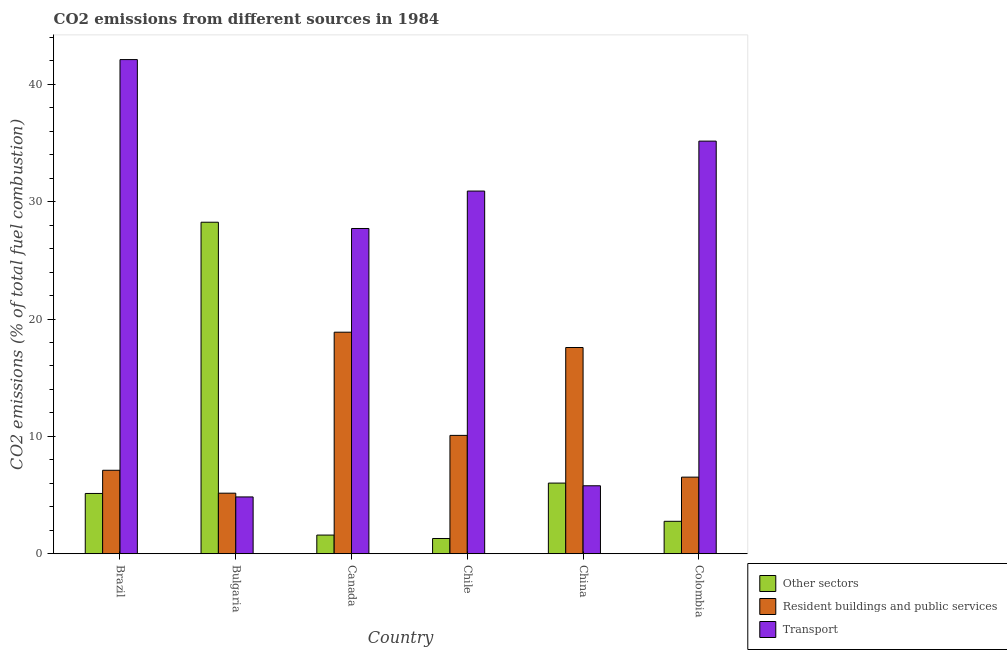How many different coloured bars are there?
Your answer should be compact. 3. How many groups of bars are there?
Give a very brief answer. 6. Are the number of bars on each tick of the X-axis equal?
Your answer should be compact. Yes. How many bars are there on the 1st tick from the right?
Your answer should be very brief. 3. What is the percentage of co2 emissions from resident buildings and public services in Brazil?
Offer a very short reply. 7.11. Across all countries, what is the maximum percentage of co2 emissions from transport?
Make the answer very short. 42.11. Across all countries, what is the minimum percentage of co2 emissions from resident buildings and public services?
Give a very brief answer. 5.16. In which country was the percentage of co2 emissions from resident buildings and public services minimum?
Provide a short and direct response. Bulgaria. What is the total percentage of co2 emissions from other sectors in the graph?
Keep it short and to the point. 45.05. What is the difference between the percentage of co2 emissions from transport in Brazil and that in Chile?
Keep it short and to the point. 11.2. What is the difference between the percentage of co2 emissions from other sectors in China and the percentage of co2 emissions from transport in Colombia?
Give a very brief answer. -29.14. What is the average percentage of co2 emissions from other sectors per country?
Your response must be concise. 7.51. What is the difference between the percentage of co2 emissions from other sectors and percentage of co2 emissions from resident buildings and public services in Chile?
Provide a short and direct response. -8.79. In how many countries, is the percentage of co2 emissions from other sectors greater than 40 %?
Provide a short and direct response. 0. What is the ratio of the percentage of co2 emissions from other sectors in Bulgaria to that in Canada?
Your answer should be compact. 17.77. Is the difference between the percentage of co2 emissions from other sectors in Chile and China greater than the difference between the percentage of co2 emissions from transport in Chile and China?
Provide a short and direct response. No. What is the difference between the highest and the second highest percentage of co2 emissions from other sectors?
Keep it short and to the point. 22.23. What is the difference between the highest and the lowest percentage of co2 emissions from resident buildings and public services?
Ensure brevity in your answer.  13.72. What does the 2nd bar from the left in China represents?
Provide a short and direct response. Resident buildings and public services. What does the 3rd bar from the right in Chile represents?
Offer a very short reply. Other sectors. How many bars are there?
Offer a terse response. 18. Are all the bars in the graph horizontal?
Ensure brevity in your answer.  No. What is the difference between two consecutive major ticks on the Y-axis?
Give a very brief answer. 10. Are the values on the major ticks of Y-axis written in scientific E-notation?
Give a very brief answer. No. Where does the legend appear in the graph?
Make the answer very short. Bottom right. How many legend labels are there?
Your answer should be compact. 3. What is the title of the graph?
Make the answer very short. CO2 emissions from different sources in 1984. What is the label or title of the X-axis?
Provide a short and direct response. Country. What is the label or title of the Y-axis?
Offer a terse response. CO2 emissions (% of total fuel combustion). What is the CO2 emissions (% of total fuel combustion) of Other sectors in Brazil?
Offer a terse response. 5.13. What is the CO2 emissions (% of total fuel combustion) of Resident buildings and public services in Brazil?
Your answer should be very brief. 7.11. What is the CO2 emissions (% of total fuel combustion) in Transport in Brazil?
Your response must be concise. 42.11. What is the CO2 emissions (% of total fuel combustion) in Other sectors in Bulgaria?
Your answer should be compact. 28.25. What is the CO2 emissions (% of total fuel combustion) of Resident buildings and public services in Bulgaria?
Offer a terse response. 5.16. What is the CO2 emissions (% of total fuel combustion) in Transport in Bulgaria?
Your response must be concise. 4.84. What is the CO2 emissions (% of total fuel combustion) of Other sectors in Canada?
Your answer should be compact. 1.59. What is the CO2 emissions (% of total fuel combustion) in Resident buildings and public services in Canada?
Make the answer very short. 18.88. What is the CO2 emissions (% of total fuel combustion) in Transport in Canada?
Provide a succinct answer. 27.71. What is the CO2 emissions (% of total fuel combustion) in Other sectors in Chile?
Ensure brevity in your answer.  1.3. What is the CO2 emissions (% of total fuel combustion) in Resident buildings and public services in Chile?
Offer a terse response. 10.08. What is the CO2 emissions (% of total fuel combustion) in Transport in Chile?
Keep it short and to the point. 30.9. What is the CO2 emissions (% of total fuel combustion) of Other sectors in China?
Ensure brevity in your answer.  6.02. What is the CO2 emissions (% of total fuel combustion) in Resident buildings and public services in China?
Your answer should be compact. 17.57. What is the CO2 emissions (% of total fuel combustion) of Transport in China?
Offer a very short reply. 5.79. What is the CO2 emissions (% of total fuel combustion) of Other sectors in Colombia?
Give a very brief answer. 2.76. What is the CO2 emissions (% of total fuel combustion) of Resident buildings and public services in Colombia?
Your response must be concise. 6.53. What is the CO2 emissions (% of total fuel combustion) of Transport in Colombia?
Your answer should be very brief. 35.16. Across all countries, what is the maximum CO2 emissions (% of total fuel combustion) of Other sectors?
Offer a terse response. 28.25. Across all countries, what is the maximum CO2 emissions (% of total fuel combustion) of Resident buildings and public services?
Make the answer very short. 18.88. Across all countries, what is the maximum CO2 emissions (% of total fuel combustion) in Transport?
Provide a short and direct response. 42.11. Across all countries, what is the minimum CO2 emissions (% of total fuel combustion) of Other sectors?
Offer a terse response. 1.3. Across all countries, what is the minimum CO2 emissions (% of total fuel combustion) in Resident buildings and public services?
Offer a terse response. 5.16. Across all countries, what is the minimum CO2 emissions (% of total fuel combustion) of Transport?
Give a very brief answer. 4.84. What is the total CO2 emissions (% of total fuel combustion) in Other sectors in the graph?
Provide a succinct answer. 45.05. What is the total CO2 emissions (% of total fuel combustion) of Resident buildings and public services in the graph?
Provide a succinct answer. 65.33. What is the total CO2 emissions (% of total fuel combustion) in Transport in the graph?
Give a very brief answer. 146.51. What is the difference between the CO2 emissions (% of total fuel combustion) of Other sectors in Brazil and that in Bulgaria?
Provide a succinct answer. -23.11. What is the difference between the CO2 emissions (% of total fuel combustion) of Resident buildings and public services in Brazil and that in Bulgaria?
Your answer should be very brief. 1.95. What is the difference between the CO2 emissions (% of total fuel combustion) of Transport in Brazil and that in Bulgaria?
Offer a very short reply. 37.27. What is the difference between the CO2 emissions (% of total fuel combustion) of Other sectors in Brazil and that in Canada?
Your answer should be compact. 3.55. What is the difference between the CO2 emissions (% of total fuel combustion) in Resident buildings and public services in Brazil and that in Canada?
Ensure brevity in your answer.  -11.77. What is the difference between the CO2 emissions (% of total fuel combustion) of Transport in Brazil and that in Canada?
Your answer should be compact. 14.39. What is the difference between the CO2 emissions (% of total fuel combustion) in Other sectors in Brazil and that in Chile?
Your response must be concise. 3.84. What is the difference between the CO2 emissions (% of total fuel combustion) in Resident buildings and public services in Brazil and that in Chile?
Make the answer very short. -2.97. What is the difference between the CO2 emissions (% of total fuel combustion) of Transport in Brazil and that in Chile?
Your answer should be compact. 11.2. What is the difference between the CO2 emissions (% of total fuel combustion) in Other sectors in Brazil and that in China?
Offer a terse response. -0.88. What is the difference between the CO2 emissions (% of total fuel combustion) of Resident buildings and public services in Brazil and that in China?
Give a very brief answer. -10.46. What is the difference between the CO2 emissions (% of total fuel combustion) of Transport in Brazil and that in China?
Your answer should be very brief. 36.32. What is the difference between the CO2 emissions (% of total fuel combustion) of Other sectors in Brazil and that in Colombia?
Your response must be concise. 2.37. What is the difference between the CO2 emissions (% of total fuel combustion) in Resident buildings and public services in Brazil and that in Colombia?
Keep it short and to the point. 0.58. What is the difference between the CO2 emissions (% of total fuel combustion) of Transport in Brazil and that in Colombia?
Keep it short and to the point. 6.95. What is the difference between the CO2 emissions (% of total fuel combustion) of Other sectors in Bulgaria and that in Canada?
Give a very brief answer. 26.66. What is the difference between the CO2 emissions (% of total fuel combustion) of Resident buildings and public services in Bulgaria and that in Canada?
Offer a terse response. -13.72. What is the difference between the CO2 emissions (% of total fuel combustion) in Transport in Bulgaria and that in Canada?
Your answer should be very brief. -22.87. What is the difference between the CO2 emissions (% of total fuel combustion) in Other sectors in Bulgaria and that in Chile?
Make the answer very short. 26.95. What is the difference between the CO2 emissions (% of total fuel combustion) of Resident buildings and public services in Bulgaria and that in Chile?
Ensure brevity in your answer.  -4.93. What is the difference between the CO2 emissions (% of total fuel combustion) of Transport in Bulgaria and that in Chile?
Your answer should be compact. -26.06. What is the difference between the CO2 emissions (% of total fuel combustion) in Other sectors in Bulgaria and that in China?
Keep it short and to the point. 22.23. What is the difference between the CO2 emissions (% of total fuel combustion) of Resident buildings and public services in Bulgaria and that in China?
Ensure brevity in your answer.  -12.41. What is the difference between the CO2 emissions (% of total fuel combustion) in Transport in Bulgaria and that in China?
Offer a very short reply. -0.95. What is the difference between the CO2 emissions (% of total fuel combustion) of Other sectors in Bulgaria and that in Colombia?
Offer a terse response. 25.48. What is the difference between the CO2 emissions (% of total fuel combustion) in Resident buildings and public services in Bulgaria and that in Colombia?
Your answer should be very brief. -1.37. What is the difference between the CO2 emissions (% of total fuel combustion) in Transport in Bulgaria and that in Colombia?
Offer a terse response. -30.32. What is the difference between the CO2 emissions (% of total fuel combustion) of Other sectors in Canada and that in Chile?
Your answer should be compact. 0.29. What is the difference between the CO2 emissions (% of total fuel combustion) in Resident buildings and public services in Canada and that in Chile?
Give a very brief answer. 8.79. What is the difference between the CO2 emissions (% of total fuel combustion) in Transport in Canada and that in Chile?
Offer a very short reply. -3.19. What is the difference between the CO2 emissions (% of total fuel combustion) in Other sectors in Canada and that in China?
Offer a very short reply. -4.43. What is the difference between the CO2 emissions (% of total fuel combustion) of Resident buildings and public services in Canada and that in China?
Offer a very short reply. 1.3. What is the difference between the CO2 emissions (% of total fuel combustion) in Transport in Canada and that in China?
Keep it short and to the point. 21.92. What is the difference between the CO2 emissions (% of total fuel combustion) in Other sectors in Canada and that in Colombia?
Keep it short and to the point. -1.17. What is the difference between the CO2 emissions (% of total fuel combustion) in Resident buildings and public services in Canada and that in Colombia?
Make the answer very short. 12.35. What is the difference between the CO2 emissions (% of total fuel combustion) in Transport in Canada and that in Colombia?
Make the answer very short. -7.45. What is the difference between the CO2 emissions (% of total fuel combustion) in Other sectors in Chile and that in China?
Your answer should be very brief. -4.72. What is the difference between the CO2 emissions (% of total fuel combustion) in Resident buildings and public services in Chile and that in China?
Your response must be concise. -7.49. What is the difference between the CO2 emissions (% of total fuel combustion) in Transport in Chile and that in China?
Provide a short and direct response. 25.11. What is the difference between the CO2 emissions (% of total fuel combustion) of Other sectors in Chile and that in Colombia?
Keep it short and to the point. -1.47. What is the difference between the CO2 emissions (% of total fuel combustion) in Resident buildings and public services in Chile and that in Colombia?
Give a very brief answer. 3.56. What is the difference between the CO2 emissions (% of total fuel combustion) in Transport in Chile and that in Colombia?
Your response must be concise. -4.25. What is the difference between the CO2 emissions (% of total fuel combustion) in Other sectors in China and that in Colombia?
Offer a very short reply. 3.26. What is the difference between the CO2 emissions (% of total fuel combustion) in Resident buildings and public services in China and that in Colombia?
Your answer should be very brief. 11.05. What is the difference between the CO2 emissions (% of total fuel combustion) in Transport in China and that in Colombia?
Your answer should be compact. -29.37. What is the difference between the CO2 emissions (% of total fuel combustion) of Other sectors in Brazil and the CO2 emissions (% of total fuel combustion) of Resident buildings and public services in Bulgaria?
Ensure brevity in your answer.  -0.02. What is the difference between the CO2 emissions (% of total fuel combustion) of Other sectors in Brazil and the CO2 emissions (% of total fuel combustion) of Transport in Bulgaria?
Provide a succinct answer. 0.3. What is the difference between the CO2 emissions (% of total fuel combustion) of Resident buildings and public services in Brazil and the CO2 emissions (% of total fuel combustion) of Transport in Bulgaria?
Offer a terse response. 2.27. What is the difference between the CO2 emissions (% of total fuel combustion) in Other sectors in Brazil and the CO2 emissions (% of total fuel combustion) in Resident buildings and public services in Canada?
Your answer should be compact. -13.74. What is the difference between the CO2 emissions (% of total fuel combustion) in Other sectors in Brazil and the CO2 emissions (% of total fuel combustion) in Transport in Canada?
Provide a succinct answer. -22.58. What is the difference between the CO2 emissions (% of total fuel combustion) in Resident buildings and public services in Brazil and the CO2 emissions (% of total fuel combustion) in Transport in Canada?
Provide a succinct answer. -20.6. What is the difference between the CO2 emissions (% of total fuel combustion) of Other sectors in Brazil and the CO2 emissions (% of total fuel combustion) of Resident buildings and public services in Chile?
Keep it short and to the point. -4.95. What is the difference between the CO2 emissions (% of total fuel combustion) in Other sectors in Brazil and the CO2 emissions (% of total fuel combustion) in Transport in Chile?
Your response must be concise. -25.77. What is the difference between the CO2 emissions (% of total fuel combustion) of Resident buildings and public services in Brazil and the CO2 emissions (% of total fuel combustion) of Transport in Chile?
Offer a terse response. -23.79. What is the difference between the CO2 emissions (% of total fuel combustion) of Other sectors in Brazil and the CO2 emissions (% of total fuel combustion) of Resident buildings and public services in China?
Keep it short and to the point. -12.44. What is the difference between the CO2 emissions (% of total fuel combustion) of Other sectors in Brazil and the CO2 emissions (% of total fuel combustion) of Transport in China?
Provide a succinct answer. -0.66. What is the difference between the CO2 emissions (% of total fuel combustion) in Resident buildings and public services in Brazil and the CO2 emissions (% of total fuel combustion) in Transport in China?
Offer a very short reply. 1.32. What is the difference between the CO2 emissions (% of total fuel combustion) of Other sectors in Brazil and the CO2 emissions (% of total fuel combustion) of Resident buildings and public services in Colombia?
Your response must be concise. -1.39. What is the difference between the CO2 emissions (% of total fuel combustion) in Other sectors in Brazil and the CO2 emissions (% of total fuel combustion) in Transport in Colombia?
Provide a short and direct response. -30.02. What is the difference between the CO2 emissions (% of total fuel combustion) of Resident buildings and public services in Brazil and the CO2 emissions (% of total fuel combustion) of Transport in Colombia?
Your answer should be compact. -28.05. What is the difference between the CO2 emissions (% of total fuel combustion) in Other sectors in Bulgaria and the CO2 emissions (% of total fuel combustion) in Resident buildings and public services in Canada?
Provide a short and direct response. 9.37. What is the difference between the CO2 emissions (% of total fuel combustion) in Other sectors in Bulgaria and the CO2 emissions (% of total fuel combustion) in Transport in Canada?
Offer a very short reply. 0.53. What is the difference between the CO2 emissions (% of total fuel combustion) in Resident buildings and public services in Bulgaria and the CO2 emissions (% of total fuel combustion) in Transport in Canada?
Offer a very short reply. -22.55. What is the difference between the CO2 emissions (% of total fuel combustion) in Other sectors in Bulgaria and the CO2 emissions (% of total fuel combustion) in Resident buildings and public services in Chile?
Your answer should be very brief. 18.16. What is the difference between the CO2 emissions (% of total fuel combustion) of Other sectors in Bulgaria and the CO2 emissions (% of total fuel combustion) of Transport in Chile?
Your answer should be compact. -2.66. What is the difference between the CO2 emissions (% of total fuel combustion) of Resident buildings and public services in Bulgaria and the CO2 emissions (% of total fuel combustion) of Transport in Chile?
Offer a terse response. -25.74. What is the difference between the CO2 emissions (% of total fuel combustion) in Other sectors in Bulgaria and the CO2 emissions (% of total fuel combustion) in Resident buildings and public services in China?
Give a very brief answer. 10.68. What is the difference between the CO2 emissions (% of total fuel combustion) of Other sectors in Bulgaria and the CO2 emissions (% of total fuel combustion) of Transport in China?
Your response must be concise. 22.46. What is the difference between the CO2 emissions (% of total fuel combustion) of Resident buildings and public services in Bulgaria and the CO2 emissions (% of total fuel combustion) of Transport in China?
Give a very brief answer. -0.63. What is the difference between the CO2 emissions (% of total fuel combustion) of Other sectors in Bulgaria and the CO2 emissions (% of total fuel combustion) of Resident buildings and public services in Colombia?
Your answer should be very brief. 21.72. What is the difference between the CO2 emissions (% of total fuel combustion) in Other sectors in Bulgaria and the CO2 emissions (% of total fuel combustion) in Transport in Colombia?
Offer a terse response. -6.91. What is the difference between the CO2 emissions (% of total fuel combustion) in Resident buildings and public services in Bulgaria and the CO2 emissions (% of total fuel combustion) in Transport in Colombia?
Keep it short and to the point. -30. What is the difference between the CO2 emissions (% of total fuel combustion) in Other sectors in Canada and the CO2 emissions (% of total fuel combustion) in Resident buildings and public services in Chile?
Your answer should be compact. -8.49. What is the difference between the CO2 emissions (% of total fuel combustion) of Other sectors in Canada and the CO2 emissions (% of total fuel combustion) of Transport in Chile?
Provide a succinct answer. -29.31. What is the difference between the CO2 emissions (% of total fuel combustion) in Resident buildings and public services in Canada and the CO2 emissions (% of total fuel combustion) in Transport in Chile?
Make the answer very short. -12.03. What is the difference between the CO2 emissions (% of total fuel combustion) in Other sectors in Canada and the CO2 emissions (% of total fuel combustion) in Resident buildings and public services in China?
Provide a succinct answer. -15.98. What is the difference between the CO2 emissions (% of total fuel combustion) of Other sectors in Canada and the CO2 emissions (% of total fuel combustion) of Transport in China?
Keep it short and to the point. -4.2. What is the difference between the CO2 emissions (% of total fuel combustion) in Resident buildings and public services in Canada and the CO2 emissions (% of total fuel combustion) in Transport in China?
Your answer should be very brief. 13.09. What is the difference between the CO2 emissions (% of total fuel combustion) in Other sectors in Canada and the CO2 emissions (% of total fuel combustion) in Resident buildings and public services in Colombia?
Offer a very short reply. -4.94. What is the difference between the CO2 emissions (% of total fuel combustion) of Other sectors in Canada and the CO2 emissions (% of total fuel combustion) of Transport in Colombia?
Provide a succinct answer. -33.57. What is the difference between the CO2 emissions (% of total fuel combustion) in Resident buildings and public services in Canada and the CO2 emissions (% of total fuel combustion) in Transport in Colombia?
Make the answer very short. -16.28. What is the difference between the CO2 emissions (% of total fuel combustion) in Other sectors in Chile and the CO2 emissions (% of total fuel combustion) in Resident buildings and public services in China?
Your response must be concise. -16.27. What is the difference between the CO2 emissions (% of total fuel combustion) of Other sectors in Chile and the CO2 emissions (% of total fuel combustion) of Transport in China?
Provide a short and direct response. -4.49. What is the difference between the CO2 emissions (% of total fuel combustion) of Resident buildings and public services in Chile and the CO2 emissions (% of total fuel combustion) of Transport in China?
Your answer should be compact. 4.29. What is the difference between the CO2 emissions (% of total fuel combustion) in Other sectors in Chile and the CO2 emissions (% of total fuel combustion) in Resident buildings and public services in Colombia?
Provide a succinct answer. -5.23. What is the difference between the CO2 emissions (% of total fuel combustion) in Other sectors in Chile and the CO2 emissions (% of total fuel combustion) in Transport in Colombia?
Provide a succinct answer. -33.86. What is the difference between the CO2 emissions (% of total fuel combustion) of Resident buildings and public services in Chile and the CO2 emissions (% of total fuel combustion) of Transport in Colombia?
Your answer should be very brief. -25.07. What is the difference between the CO2 emissions (% of total fuel combustion) in Other sectors in China and the CO2 emissions (% of total fuel combustion) in Resident buildings and public services in Colombia?
Your response must be concise. -0.51. What is the difference between the CO2 emissions (% of total fuel combustion) in Other sectors in China and the CO2 emissions (% of total fuel combustion) in Transport in Colombia?
Offer a very short reply. -29.14. What is the difference between the CO2 emissions (% of total fuel combustion) in Resident buildings and public services in China and the CO2 emissions (% of total fuel combustion) in Transport in Colombia?
Your response must be concise. -17.59. What is the average CO2 emissions (% of total fuel combustion) in Other sectors per country?
Offer a terse response. 7.51. What is the average CO2 emissions (% of total fuel combustion) in Resident buildings and public services per country?
Offer a terse response. 10.89. What is the average CO2 emissions (% of total fuel combustion) of Transport per country?
Ensure brevity in your answer.  24.42. What is the difference between the CO2 emissions (% of total fuel combustion) of Other sectors and CO2 emissions (% of total fuel combustion) of Resident buildings and public services in Brazil?
Offer a terse response. -1.98. What is the difference between the CO2 emissions (% of total fuel combustion) of Other sectors and CO2 emissions (% of total fuel combustion) of Transport in Brazil?
Ensure brevity in your answer.  -36.97. What is the difference between the CO2 emissions (% of total fuel combustion) in Resident buildings and public services and CO2 emissions (% of total fuel combustion) in Transport in Brazil?
Offer a very short reply. -34.99. What is the difference between the CO2 emissions (% of total fuel combustion) of Other sectors and CO2 emissions (% of total fuel combustion) of Resident buildings and public services in Bulgaria?
Make the answer very short. 23.09. What is the difference between the CO2 emissions (% of total fuel combustion) of Other sectors and CO2 emissions (% of total fuel combustion) of Transport in Bulgaria?
Give a very brief answer. 23.41. What is the difference between the CO2 emissions (% of total fuel combustion) of Resident buildings and public services and CO2 emissions (% of total fuel combustion) of Transport in Bulgaria?
Your response must be concise. 0.32. What is the difference between the CO2 emissions (% of total fuel combustion) in Other sectors and CO2 emissions (% of total fuel combustion) in Resident buildings and public services in Canada?
Make the answer very short. -17.29. What is the difference between the CO2 emissions (% of total fuel combustion) in Other sectors and CO2 emissions (% of total fuel combustion) in Transport in Canada?
Offer a terse response. -26.12. What is the difference between the CO2 emissions (% of total fuel combustion) in Resident buildings and public services and CO2 emissions (% of total fuel combustion) in Transport in Canada?
Ensure brevity in your answer.  -8.84. What is the difference between the CO2 emissions (% of total fuel combustion) of Other sectors and CO2 emissions (% of total fuel combustion) of Resident buildings and public services in Chile?
Your answer should be compact. -8.79. What is the difference between the CO2 emissions (% of total fuel combustion) in Other sectors and CO2 emissions (% of total fuel combustion) in Transport in Chile?
Provide a succinct answer. -29.61. What is the difference between the CO2 emissions (% of total fuel combustion) of Resident buildings and public services and CO2 emissions (% of total fuel combustion) of Transport in Chile?
Give a very brief answer. -20.82. What is the difference between the CO2 emissions (% of total fuel combustion) in Other sectors and CO2 emissions (% of total fuel combustion) in Resident buildings and public services in China?
Make the answer very short. -11.55. What is the difference between the CO2 emissions (% of total fuel combustion) in Other sectors and CO2 emissions (% of total fuel combustion) in Transport in China?
Offer a very short reply. 0.23. What is the difference between the CO2 emissions (% of total fuel combustion) of Resident buildings and public services and CO2 emissions (% of total fuel combustion) of Transport in China?
Provide a succinct answer. 11.78. What is the difference between the CO2 emissions (% of total fuel combustion) of Other sectors and CO2 emissions (% of total fuel combustion) of Resident buildings and public services in Colombia?
Provide a succinct answer. -3.76. What is the difference between the CO2 emissions (% of total fuel combustion) of Other sectors and CO2 emissions (% of total fuel combustion) of Transport in Colombia?
Give a very brief answer. -32.39. What is the difference between the CO2 emissions (% of total fuel combustion) in Resident buildings and public services and CO2 emissions (% of total fuel combustion) in Transport in Colombia?
Make the answer very short. -28.63. What is the ratio of the CO2 emissions (% of total fuel combustion) in Other sectors in Brazil to that in Bulgaria?
Keep it short and to the point. 0.18. What is the ratio of the CO2 emissions (% of total fuel combustion) of Resident buildings and public services in Brazil to that in Bulgaria?
Provide a short and direct response. 1.38. What is the ratio of the CO2 emissions (% of total fuel combustion) in Transport in Brazil to that in Bulgaria?
Make the answer very short. 8.7. What is the ratio of the CO2 emissions (% of total fuel combustion) of Other sectors in Brazil to that in Canada?
Your answer should be compact. 3.23. What is the ratio of the CO2 emissions (% of total fuel combustion) of Resident buildings and public services in Brazil to that in Canada?
Ensure brevity in your answer.  0.38. What is the ratio of the CO2 emissions (% of total fuel combustion) in Transport in Brazil to that in Canada?
Ensure brevity in your answer.  1.52. What is the ratio of the CO2 emissions (% of total fuel combustion) of Other sectors in Brazil to that in Chile?
Keep it short and to the point. 3.96. What is the ratio of the CO2 emissions (% of total fuel combustion) in Resident buildings and public services in Brazil to that in Chile?
Your response must be concise. 0.71. What is the ratio of the CO2 emissions (% of total fuel combustion) in Transport in Brazil to that in Chile?
Your answer should be compact. 1.36. What is the ratio of the CO2 emissions (% of total fuel combustion) of Other sectors in Brazil to that in China?
Your answer should be compact. 0.85. What is the ratio of the CO2 emissions (% of total fuel combustion) of Resident buildings and public services in Brazil to that in China?
Your response must be concise. 0.4. What is the ratio of the CO2 emissions (% of total fuel combustion) in Transport in Brazil to that in China?
Offer a very short reply. 7.27. What is the ratio of the CO2 emissions (% of total fuel combustion) in Other sectors in Brazil to that in Colombia?
Your answer should be very brief. 1.86. What is the ratio of the CO2 emissions (% of total fuel combustion) in Resident buildings and public services in Brazil to that in Colombia?
Your answer should be compact. 1.09. What is the ratio of the CO2 emissions (% of total fuel combustion) in Transport in Brazil to that in Colombia?
Provide a short and direct response. 1.2. What is the ratio of the CO2 emissions (% of total fuel combustion) in Other sectors in Bulgaria to that in Canada?
Make the answer very short. 17.77. What is the ratio of the CO2 emissions (% of total fuel combustion) in Resident buildings and public services in Bulgaria to that in Canada?
Your answer should be very brief. 0.27. What is the ratio of the CO2 emissions (% of total fuel combustion) of Transport in Bulgaria to that in Canada?
Give a very brief answer. 0.17. What is the ratio of the CO2 emissions (% of total fuel combustion) in Other sectors in Bulgaria to that in Chile?
Provide a short and direct response. 21.76. What is the ratio of the CO2 emissions (% of total fuel combustion) in Resident buildings and public services in Bulgaria to that in Chile?
Provide a short and direct response. 0.51. What is the ratio of the CO2 emissions (% of total fuel combustion) in Transport in Bulgaria to that in Chile?
Provide a short and direct response. 0.16. What is the ratio of the CO2 emissions (% of total fuel combustion) of Other sectors in Bulgaria to that in China?
Ensure brevity in your answer.  4.69. What is the ratio of the CO2 emissions (% of total fuel combustion) of Resident buildings and public services in Bulgaria to that in China?
Your answer should be compact. 0.29. What is the ratio of the CO2 emissions (% of total fuel combustion) of Transport in Bulgaria to that in China?
Provide a succinct answer. 0.84. What is the ratio of the CO2 emissions (% of total fuel combustion) of Other sectors in Bulgaria to that in Colombia?
Give a very brief answer. 10.22. What is the ratio of the CO2 emissions (% of total fuel combustion) of Resident buildings and public services in Bulgaria to that in Colombia?
Keep it short and to the point. 0.79. What is the ratio of the CO2 emissions (% of total fuel combustion) of Transport in Bulgaria to that in Colombia?
Keep it short and to the point. 0.14. What is the ratio of the CO2 emissions (% of total fuel combustion) in Other sectors in Canada to that in Chile?
Give a very brief answer. 1.22. What is the ratio of the CO2 emissions (% of total fuel combustion) of Resident buildings and public services in Canada to that in Chile?
Provide a short and direct response. 1.87. What is the ratio of the CO2 emissions (% of total fuel combustion) of Transport in Canada to that in Chile?
Your answer should be compact. 0.9. What is the ratio of the CO2 emissions (% of total fuel combustion) in Other sectors in Canada to that in China?
Give a very brief answer. 0.26. What is the ratio of the CO2 emissions (% of total fuel combustion) of Resident buildings and public services in Canada to that in China?
Offer a terse response. 1.07. What is the ratio of the CO2 emissions (% of total fuel combustion) of Transport in Canada to that in China?
Make the answer very short. 4.79. What is the ratio of the CO2 emissions (% of total fuel combustion) in Other sectors in Canada to that in Colombia?
Make the answer very short. 0.58. What is the ratio of the CO2 emissions (% of total fuel combustion) of Resident buildings and public services in Canada to that in Colombia?
Your answer should be very brief. 2.89. What is the ratio of the CO2 emissions (% of total fuel combustion) in Transport in Canada to that in Colombia?
Give a very brief answer. 0.79. What is the ratio of the CO2 emissions (% of total fuel combustion) of Other sectors in Chile to that in China?
Provide a succinct answer. 0.22. What is the ratio of the CO2 emissions (% of total fuel combustion) of Resident buildings and public services in Chile to that in China?
Your answer should be compact. 0.57. What is the ratio of the CO2 emissions (% of total fuel combustion) in Transport in Chile to that in China?
Offer a terse response. 5.34. What is the ratio of the CO2 emissions (% of total fuel combustion) in Other sectors in Chile to that in Colombia?
Ensure brevity in your answer.  0.47. What is the ratio of the CO2 emissions (% of total fuel combustion) of Resident buildings and public services in Chile to that in Colombia?
Offer a terse response. 1.55. What is the ratio of the CO2 emissions (% of total fuel combustion) in Transport in Chile to that in Colombia?
Your answer should be compact. 0.88. What is the ratio of the CO2 emissions (% of total fuel combustion) in Other sectors in China to that in Colombia?
Your answer should be compact. 2.18. What is the ratio of the CO2 emissions (% of total fuel combustion) of Resident buildings and public services in China to that in Colombia?
Make the answer very short. 2.69. What is the ratio of the CO2 emissions (% of total fuel combustion) of Transport in China to that in Colombia?
Provide a succinct answer. 0.16. What is the difference between the highest and the second highest CO2 emissions (% of total fuel combustion) in Other sectors?
Provide a succinct answer. 22.23. What is the difference between the highest and the second highest CO2 emissions (% of total fuel combustion) of Resident buildings and public services?
Your answer should be compact. 1.3. What is the difference between the highest and the second highest CO2 emissions (% of total fuel combustion) in Transport?
Ensure brevity in your answer.  6.95. What is the difference between the highest and the lowest CO2 emissions (% of total fuel combustion) of Other sectors?
Make the answer very short. 26.95. What is the difference between the highest and the lowest CO2 emissions (% of total fuel combustion) in Resident buildings and public services?
Offer a very short reply. 13.72. What is the difference between the highest and the lowest CO2 emissions (% of total fuel combustion) of Transport?
Give a very brief answer. 37.27. 